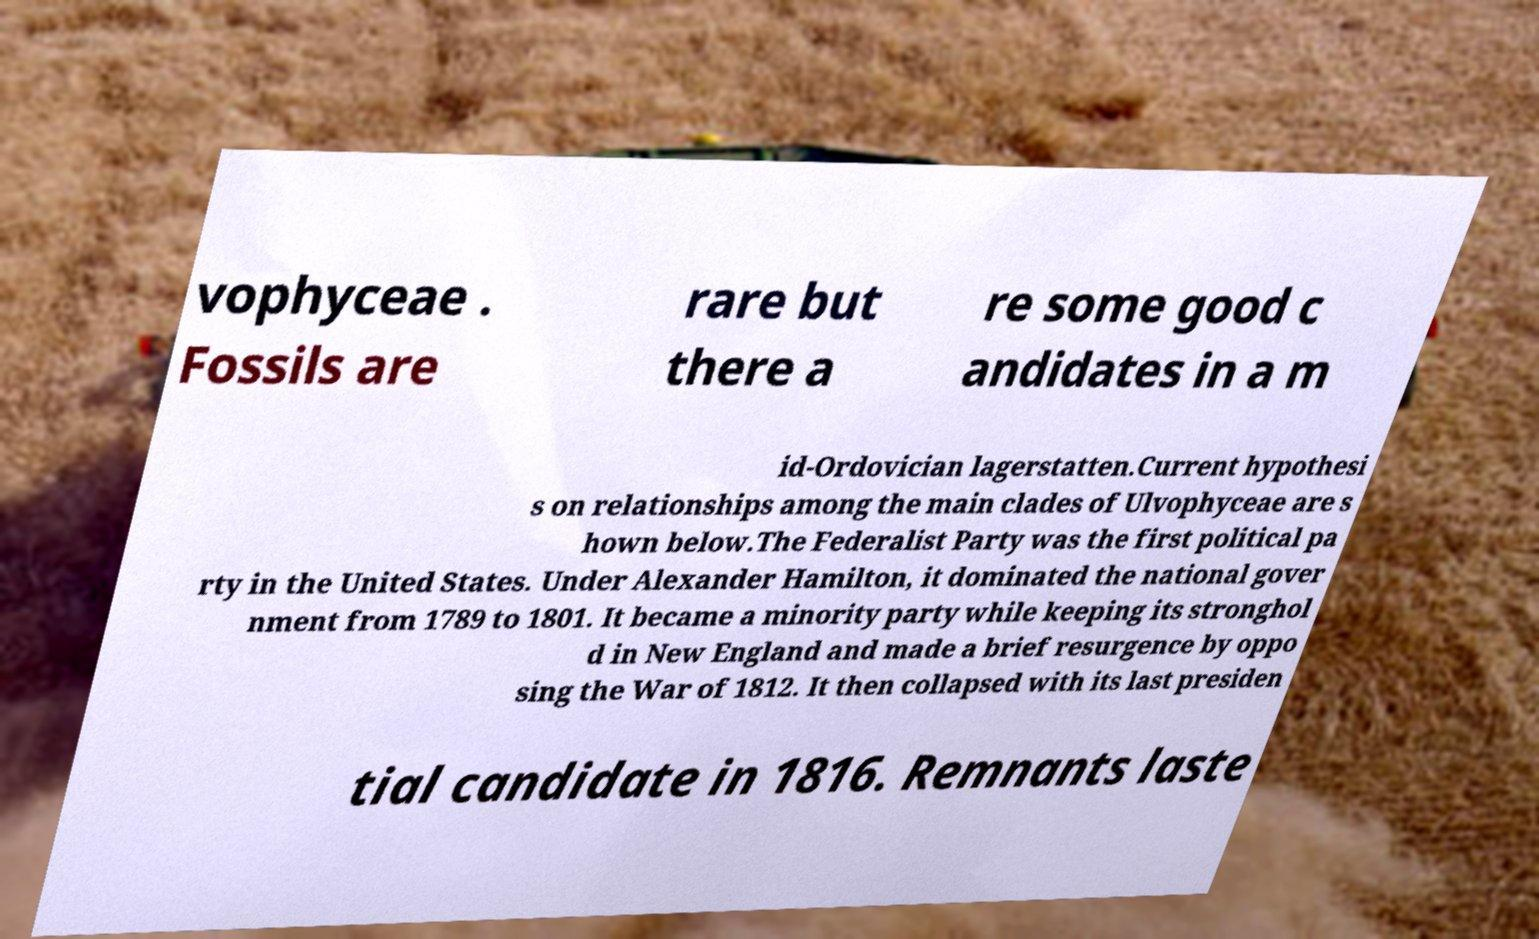Could you extract and type out the text from this image? vophyceae . Fossils are rare but there a re some good c andidates in a m id-Ordovician lagerstatten.Current hypothesi s on relationships among the main clades of Ulvophyceae are s hown below.The Federalist Party was the first political pa rty in the United States. Under Alexander Hamilton, it dominated the national gover nment from 1789 to 1801. It became a minority party while keeping its stronghol d in New England and made a brief resurgence by oppo sing the War of 1812. It then collapsed with its last presiden tial candidate in 1816. Remnants laste 